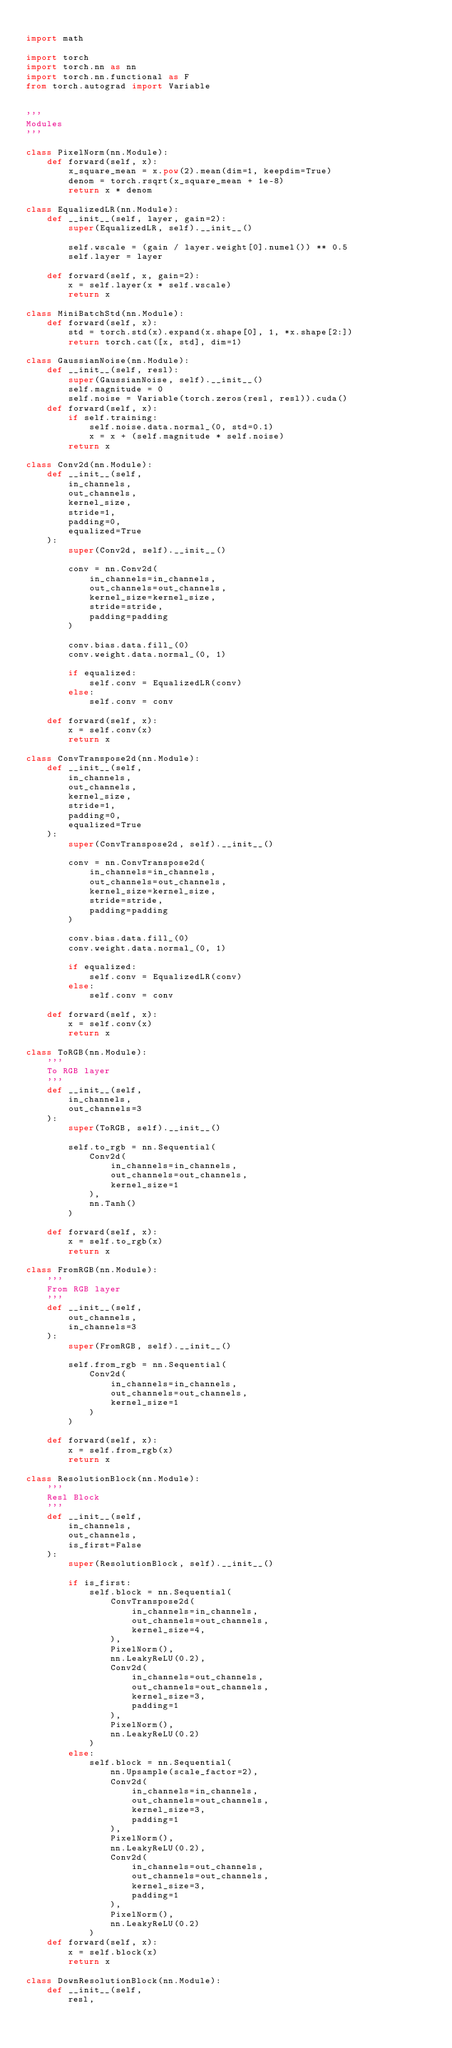Convert code to text. <code><loc_0><loc_0><loc_500><loc_500><_Python_>
import math

import torch
import torch.nn as nn
import torch.nn.functional as F
from torch.autograd import Variable


'''
Modules
'''

class PixelNorm(nn.Module):
    def forward(self, x):
        x_square_mean = x.pow(2).mean(dim=1, keepdim=True)
        denom = torch.rsqrt(x_square_mean + 1e-8)
        return x * denom

class EqualizedLR(nn.Module):
    def __init__(self, layer, gain=2):
        super(EqualizedLR, self).__init__()

        self.wscale = (gain / layer.weight[0].numel()) ** 0.5
        self.layer = layer

    def forward(self, x, gain=2):
        x = self.layer(x * self.wscale)
        return x

class MiniBatchStd(nn.Module):
    def forward(self, x):
        std = torch.std(x).expand(x.shape[0], 1, *x.shape[2:])
        return torch.cat([x, std], dim=1)

class GaussianNoise(nn.Module):
    def __init__(self, resl):
        super(GaussianNoise, self).__init__()
        self.magnitude = 0
        self.noise = Variable(torch.zeros(resl, resl)).cuda()
    def forward(self, x):
        if self.training:
            self.noise.data.normal_(0, std=0.1)
            x = x + (self.magnitude * self.noise)
        return x

class Conv2d(nn.Module):
    def __init__(self,
        in_channels,
        out_channels,
        kernel_size,
        stride=1,
        padding=0,
        equalized=True
    ):
        super(Conv2d, self).__init__()

        conv = nn.Conv2d(
            in_channels=in_channels,
            out_channels=out_channels,
            kernel_size=kernel_size,
            stride=stride,
            padding=padding
        )

        conv.bias.data.fill_(0)
        conv.weight.data.normal_(0, 1)

        if equalized:
            self.conv = EqualizedLR(conv)
        else:
            self.conv = conv

    def forward(self, x):
        x = self.conv(x)
        return x

class ConvTranspose2d(nn.Module):
    def __init__(self,
        in_channels,
        out_channels,
        kernel_size,
        stride=1,
        padding=0,
        equalized=True
    ):
        super(ConvTranspose2d, self).__init__()

        conv = nn.ConvTranspose2d(
            in_channels=in_channels,
            out_channels=out_channels,
            kernel_size=kernel_size,
            stride=stride,
            padding=padding
        )

        conv.bias.data.fill_(0)
        conv.weight.data.normal_(0, 1)

        if equalized:
            self.conv = EqualizedLR(conv)
        else:
            self.conv = conv

    def forward(self, x):
        x = self.conv(x)
        return x

class ToRGB(nn.Module):
    '''
    To RGB layer
    '''
    def __init__(self,
        in_channels,
        out_channels=3
    ):
        super(ToRGB, self).__init__()

        self.to_rgb = nn.Sequential(
            Conv2d(
                in_channels=in_channels,
                out_channels=out_channels,
                kernel_size=1
            ),
            nn.Tanh()
        )

    def forward(self, x):
        x = self.to_rgb(x)
        return x

class FromRGB(nn.Module):
    '''
    From RGB layer
    '''
    def __init__(self,
        out_channels,
        in_channels=3
    ):
        super(FromRGB, self).__init__()

        self.from_rgb = nn.Sequential(
            Conv2d(
                in_channels=in_channels,
                out_channels=out_channels,
                kernel_size=1
            )
        )

    def forward(self, x):
        x = self.from_rgb(x)
        return x

class ResolutionBlock(nn.Module):
    '''
    Resl Block
    '''
    def __init__(self,
        in_channels,
        out_channels,
        is_first=False
    ):
        super(ResolutionBlock, self).__init__()

        if is_first:
            self.block = nn.Sequential(
                ConvTranspose2d(
                    in_channels=in_channels,
                    out_channels=out_channels,
                    kernel_size=4,
                ),
                PixelNorm(),
                nn.LeakyReLU(0.2),
                Conv2d(
                    in_channels=out_channels,
                    out_channels=out_channels,
                    kernel_size=3,
                    padding=1
                ),
                PixelNorm(),
                nn.LeakyReLU(0.2)
            )
        else:
            self.block = nn.Sequential(
                nn.Upsample(scale_factor=2),
                Conv2d(
                    in_channels=in_channels,
                    out_channels=out_channels,
                    kernel_size=3,
                    padding=1
                ),
                PixelNorm(),
                nn.LeakyReLU(0.2),
                Conv2d(
                    in_channels=out_channels,
                    out_channels=out_channels,
                    kernel_size=3,
                    padding=1
                ),
                PixelNorm(),
                nn.LeakyReLU(0.2)
            )
    def forward(self, x):
        x = self.block(x)
        return x

class DownResolutionBlock(nn.Module):
    def __init__(self,
        resl,</code> 